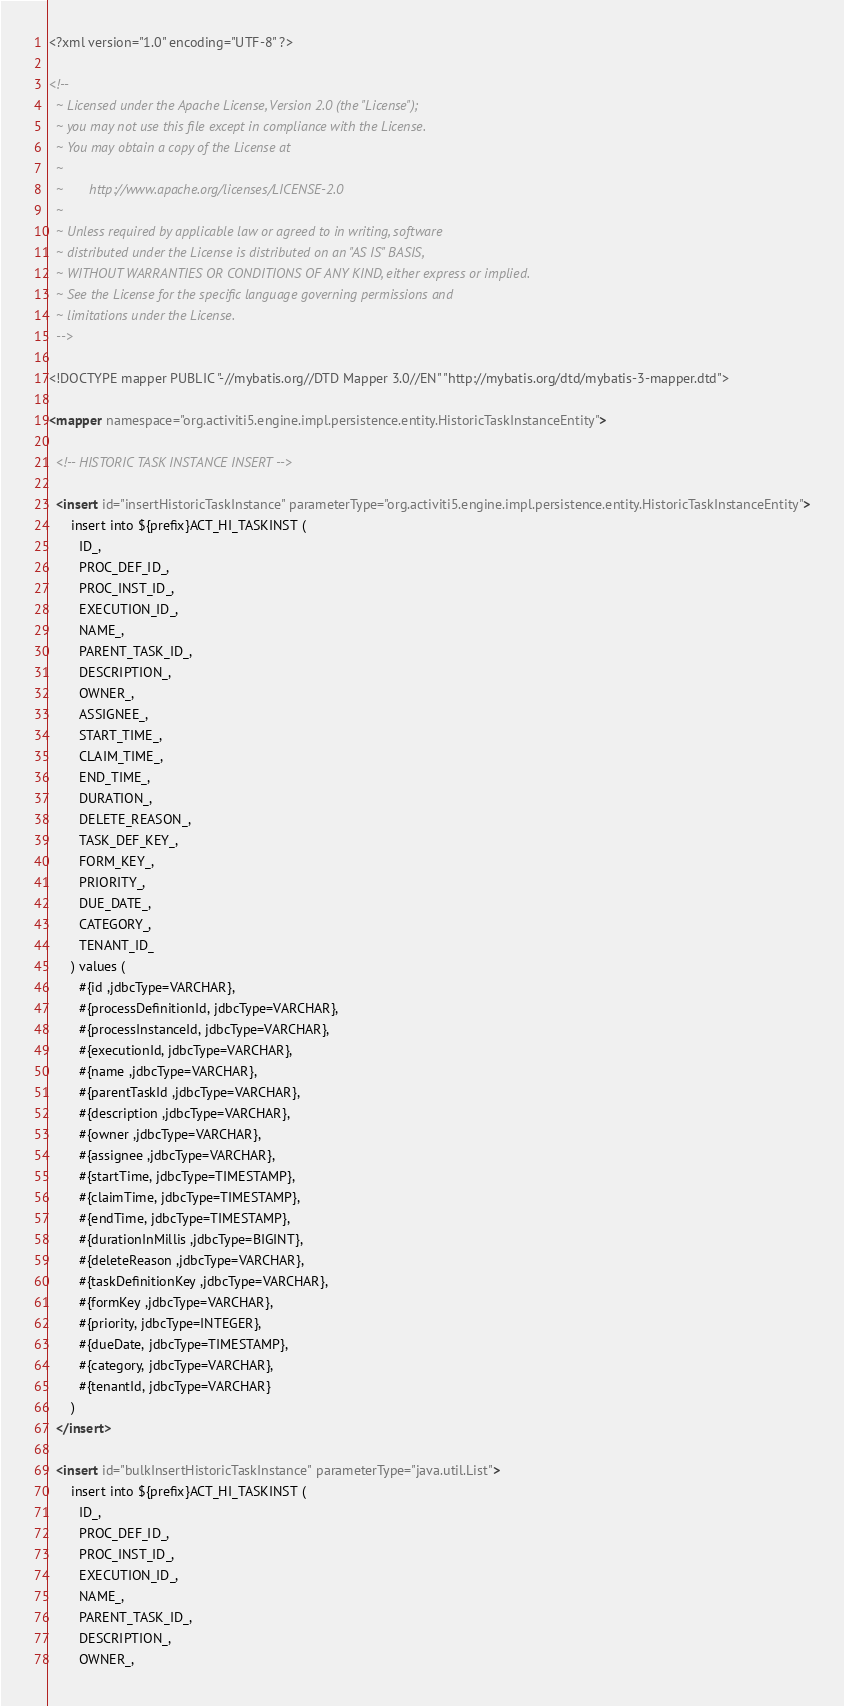<code> <loc_0><loc_0><loc_500><loc_500><_XML_><?xml version="1.0" encoding="UTF-8" ?>

<!--
  ~ Licensed under the Apache License, Version 2.0 (the "License");
  ~ you may not use this file except in compliance with the License.
  ~ You may obtain a copy of the License at
  ~
  ~       http://www.apache.org/licenses/LICENSE-2.0
  ~
  ~ Unless required by applicable law or agreed to in writing, software
  ~ distributed under the License is distributed on an "AS IS" BASIS,
  ~ WITHOUT WARRANTIES OR CONDITIONS OF ANY KIND, either express or implied.
  ~ See the License for the specific language governing permissions and
  ~ limitations under the License.
  -->

<!DOCTYPE mapper PUBLIC "-//mybatis.org//DTD Mapper 3.0//EN" "http://mybatis.org/dtd/mybatis-3-mapper.dtd">

<mapper namespace="org.activiti5.engine.impl.persistence.entity.HistoricTaskInstanceEntity">
  
  <!-- HISTORIC TASK INSTANCE INSERT -->
  
  <insert id="insertHistoricTaskInstance" parameterType="org.activiti5.engine.impl.persistence.entity.HistoricTaskInstanceEntity">
      insert into ${prefix}ACT_HI_TASKINST (
        ID_,
        PROC_DEF_ID_,
        PROC_INST_ID_,
        EXECUTION_ID_,
        NAME_,
        PARENT_TASK_ID_,
        DESCRIPTION_,
        OWNER_,
        ASSIGNEE_,
        START_TIME_,
        CLAIM_TIME_,
        END_TIME_,
        DURATION_,
        DELETE_REASON_,
        TASK_DEF_KEY_,
        FORM_KEY_,
        PRIORITY_,
        DUE_DATE_,
        CATEGORY_,
        TENANT_ID_
      ) values (
        #{id ,jdbcType=VARCHAR},
        #{processDefinitionId, jdbcType=VARCHAR},
        #{processInstanceId, jdbcType=VARCHAR},
        #{executionId, jdbcType=VARCHAR},
        #{name ,jdbcType=VARCHAR},
        #{parentTaskId ,jdbcType=VARCHAR},
        #{description ,jdbcType=VARCHAR},
        #{owner ,jdbcType=VARCHAR},
        #{assignee ,jdbcType=VARCHAR},
        #{startTime, jdbcType=TIMESTAMP},
        #{claimTime, jdbcType=TIMESTAMP},
        #{endTime, jdbcType=TIMESTAMP},
        #{durationInMillis ,jdbcType=BIGINT},
        #{deleteReason ,jdbcType=VARCHAR},
        #{taskDefinitionKey ,jdbcType=VARCHAR},
        #{formKey ,jdbcType=VARCHAR},
        #{priority, jdbcType=INTEGER},
        #{dueDate, jdbcType=TIMESTAMP},
        #{category, jdbcType=VARCHAR},
        #{tenantId, jdbcType=VARCHAR}
      )
  </insert>

  <insert id="bulkInsertHistoricTaskInstance" parameterType="java.util.List">
      insert into ${prefix}ACT_HI_TASKINST (
        ID_,
        PROC_DEF_ID_,
        PROC_INST_ID_,
        EXECUTION_ID_,
        NAME_,
        PARENT_TASK_ID_,
        DESCRIPTION_,
        OWNER_,</code> 